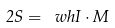Convert formula to latex. <formula><loc_0><loc_0><loc_500><loc_500>2 { S } = { \ w h I } \cdot { M }</formula> 